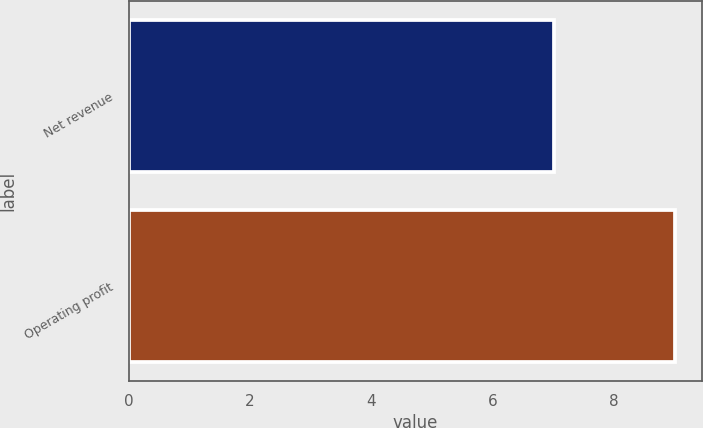Convert chart to OTSL. <chart><loc_0><loc_0><loc_500><loc_500><bar_chart><fcel>Net revenue<fcel>Operating profit<nl><fcel>7<fcel>9<nl></chart> 